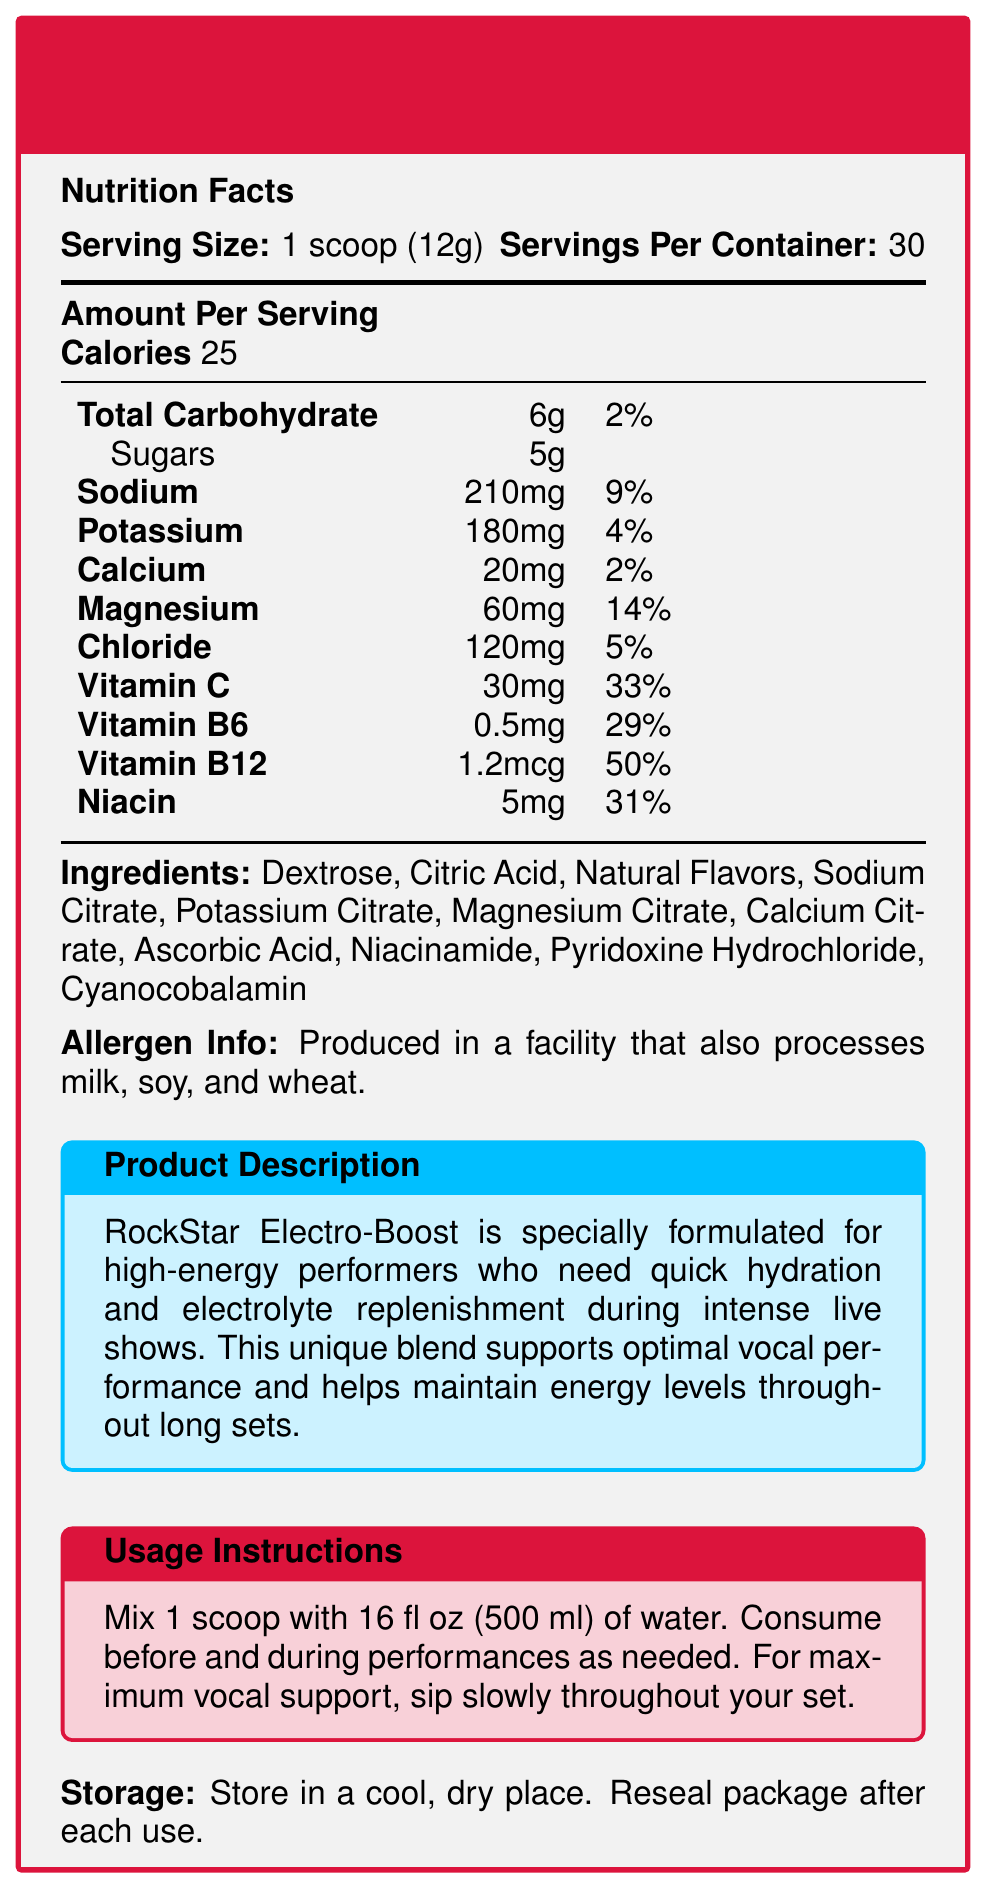what is the serving size of the RockStar Electro-Boost Powder Mix? The document states that the serving size is "1 scoop (12g)".
Answer: 1 scoop (12g) how many servings are there per container? The document indicates that there are 30 servings per container.
Answer: 30 how many calories are in one serving of the powder mix? The document lists the number of calories per serving as 25.
Answer: 25 how much sodium is in each serving? The sodium content per serving is mentioned as 210mg.
Answer: 210mg what percentage of the daily value of vitamin B12 does one serving provide? The document states that one serving provides 50% of the daily value for vitamin B12.
Answer: 50% which ingredient is not listed in the document? A. Dextrose B. Sodium Citrate C. Sugar D. Niacinamide Ingredients listed are Dextrose, Citric Acid, Natural Flavors, Sodium Citrate, Potassium Citrate, Magnesium Citrate, Calcium Citrate, Ascorbic Acid, Niacinamide, Pyridoxine Hydrochloride, and Cyanocobalamin; "Sugar" is not listed.
Answer: C. Sugar how much magnesium is present in one serving? A. 20mg B. 60mg C. 120mg D. 210mg The document lists magnesium content per serving as 60mg.
Answer: B. 60mg is the powder mix suitable for someone with a wheat allergy? The allergen information states that the product is produced in a facility that processes wheat.
Answer: No describe the main idea of the document. The document provides comprehensive information about the RockStar Electro-Boost Powder Mix, including its nutritional composition, intended use, ingredients, allergen information, and instructions for use and storage. It highlights the product's benefits for performers needing hydration and energy.
Answer: The RockStar Electro-Boost Powder Mix is an electrolyte supplement designed for high-energy performers. It includes various vitamins and minerals to support hydration and energy levels. The product details include nutritional information, ingredient list, allergen info, product description, usage instructions, and storage guidelines. what are the exact usage instructions for the powder mix? The document provides explicit usage instructions for the optimal consumption of the product during performances.
Answer: Mix 1 scoop with 16 fl oz (500 ml) of water. Consume before and during performances as needed. For maximum vocal support, sip slowly throughout your set. can you determine the exact amount of protein in one serving of the powder mix? The document does not provide any information about protein content.
Answer: Cannot be determined 